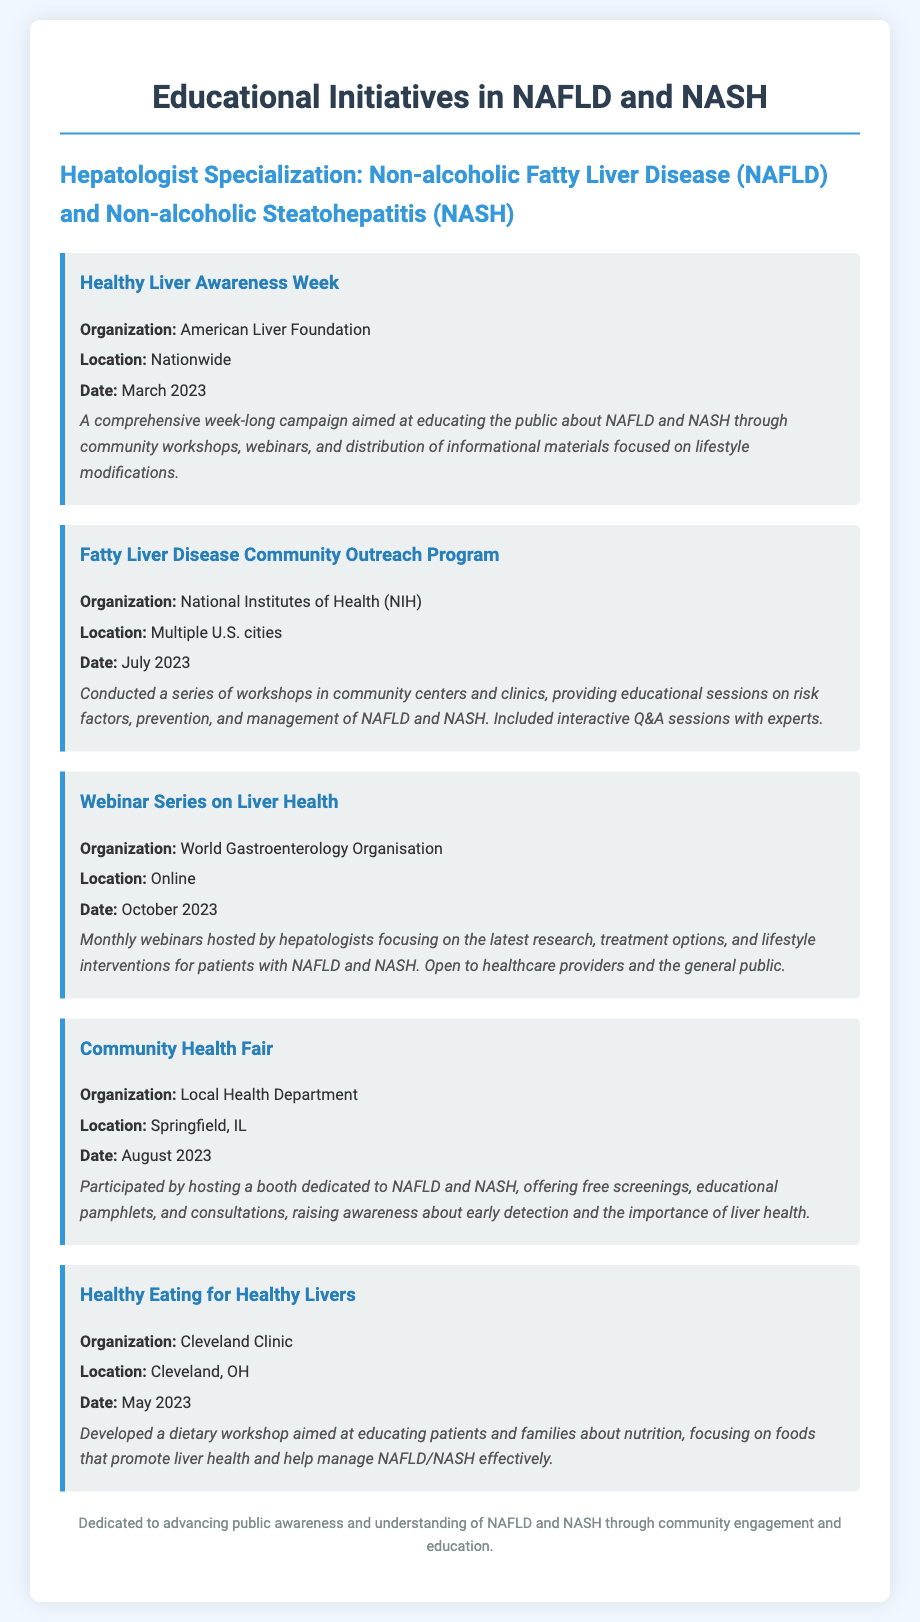What is the title of the document? The title of the document is stated in the `<title>` tag.
Answer: Educational Initiatives in NAFLD and NASH Which organization's initiative focuses on Healthy Liver Awareness Week? The organization listed for this initiative is mentioned in the corresponding section.
Answer: American Liver Foundation What is the date of the Fatty Liver Disease Community Outreach Program? The date can be found in the details of that specific initiative section.
Answer: July 2023 Where was the Community Health Fair held? The location of the event is specifically noted in the document.
Answer: Springfield, IL What type of event is the "Webinar Series on Liver Health"? The type of event is described in the title and details of the corresponding initiative.
Answer: Monthly webinars Which workshop was developed by the Cleveland Clinic? The workshop details provide insight into what it specifically targets.
Answer: Healthy Eating for Healthy Livers How many initiatives are listed in the document? The total number of initiatives can be counted from the sections described.
Answer: Five What is the goal of the Healthy Liver Awareness Week campaign? The goal is summarized in the description of that specific initiative.
Answer: Educating the public about NAFLD and NASH Who is the target audience for the Webinar Series on Liver Health? The target audience is clarified in the details of the initiative description.
Answer: Healthcare providers and the general public 